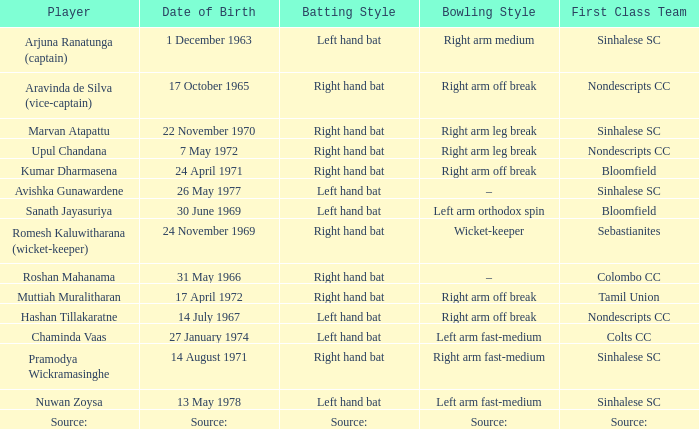What top-tier team does sanath jayasuriya represent? Bloomfield. 